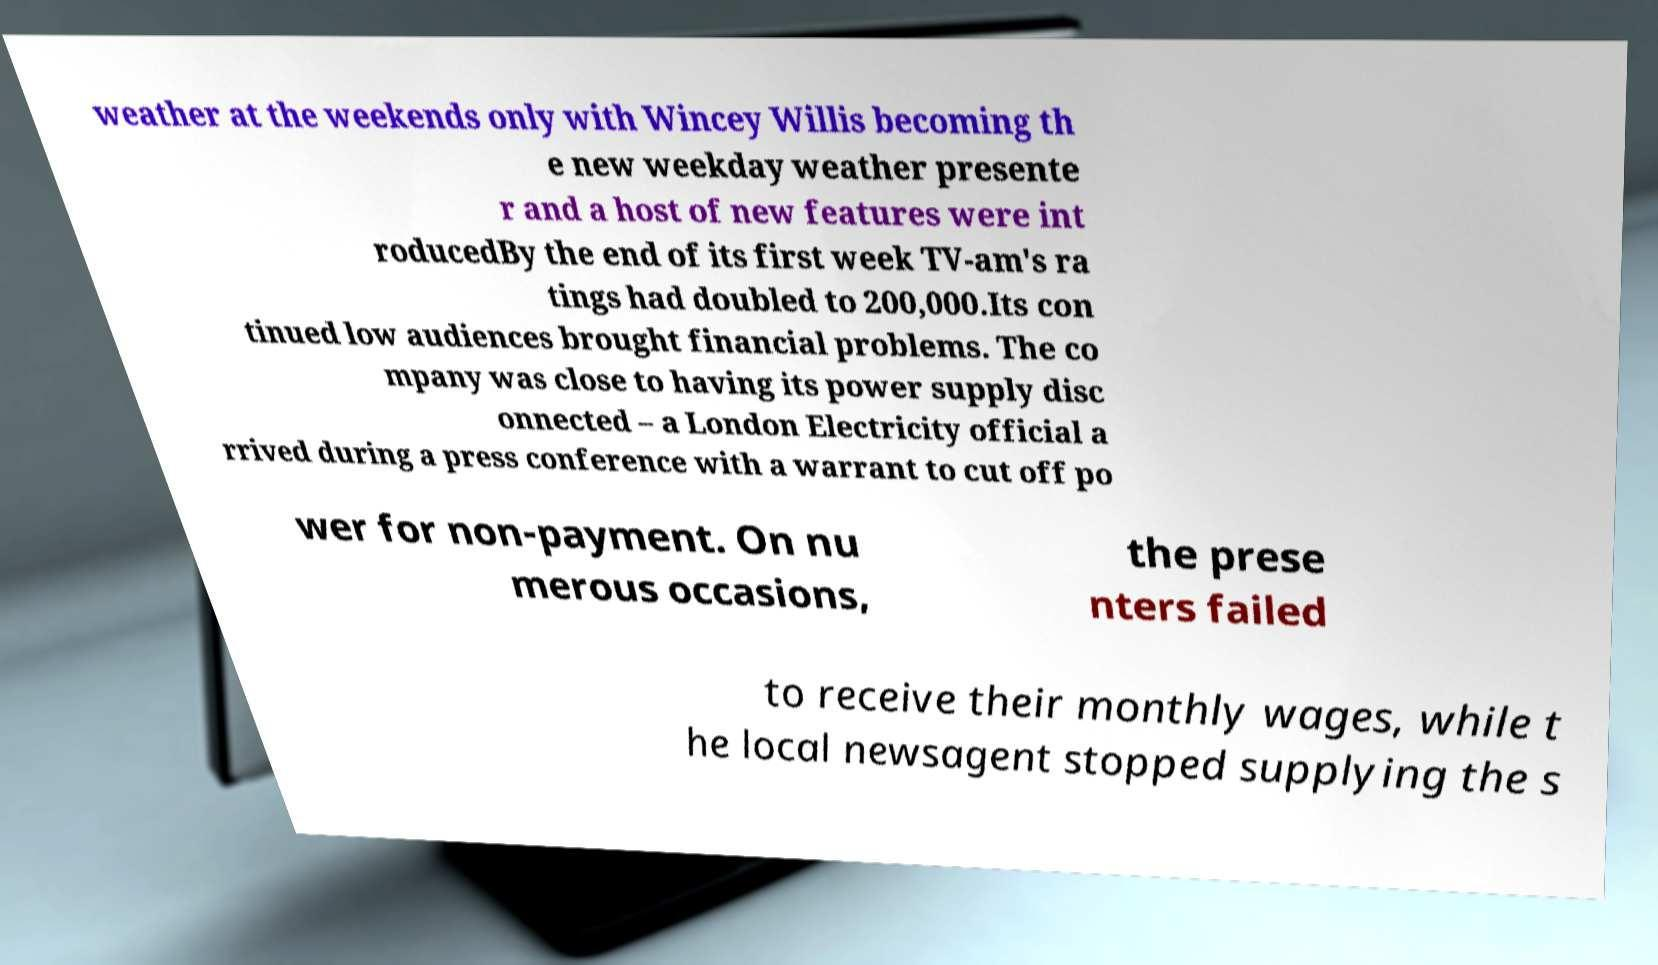Please read and relay the text visible in this image. What does it say? weather at the weekends only with Wincey Willis becoming th e new weekday weather presente r and a host of new features were int roducedBy the end of its first week TV-am's ra tings had doubled to 200,000.Its con tinued low audiences brought financial problems. The co mpany was close to having its power supply disc onnected – a London Electricity official a rrived during a press conference with a warrant to cut off po wer for non-payment. On nu merous occasions, the prese nters failed to receive their monthly wages, while t he local newsagent stopped supplying the s 